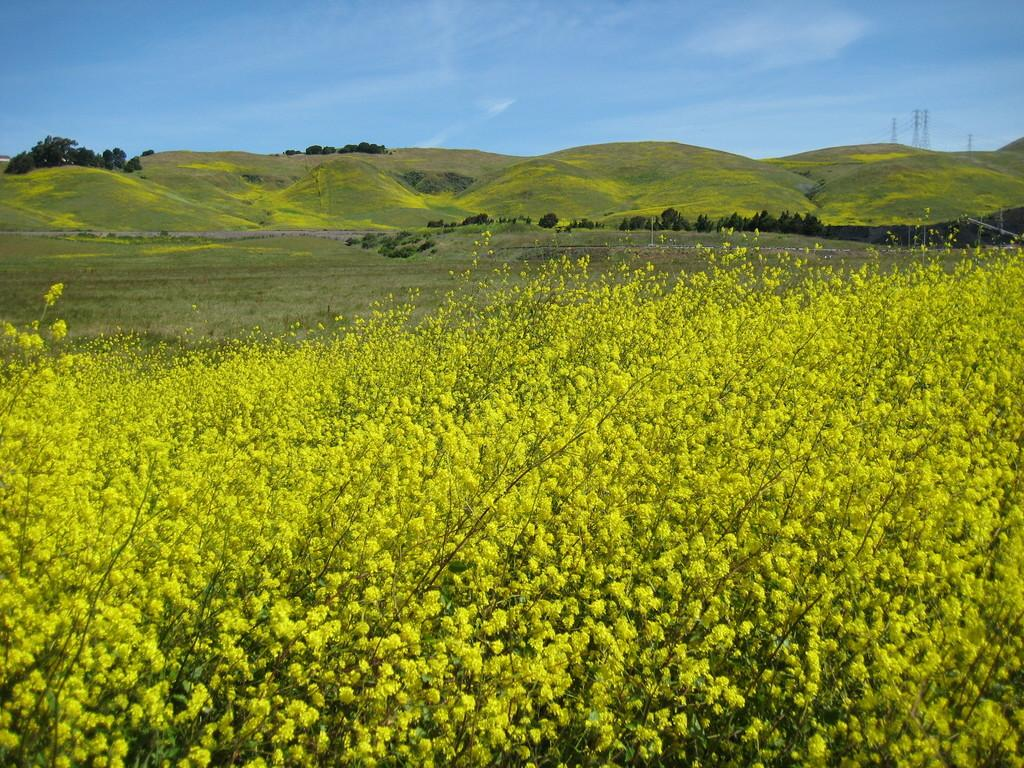What type of living organisms can be seen in the image? Plants can be seen in the image. What type of natural formation is visible in the image? Mountains can be seen in the image. What are the poles in the image used for? The purpose of the poles in the image is not specified, but they could be used for various purposes such as signage or supporting structures. What part of the natural environment is visible in the image? The sky is visible in the background of the image. What type of ink can be seen flowing from the mountains in the image? There is no ink visible in the image; it features plants, mountains, and poles. What question is being asked by the plants in the image? There is no indication in the image that the plants are asking any questions. 